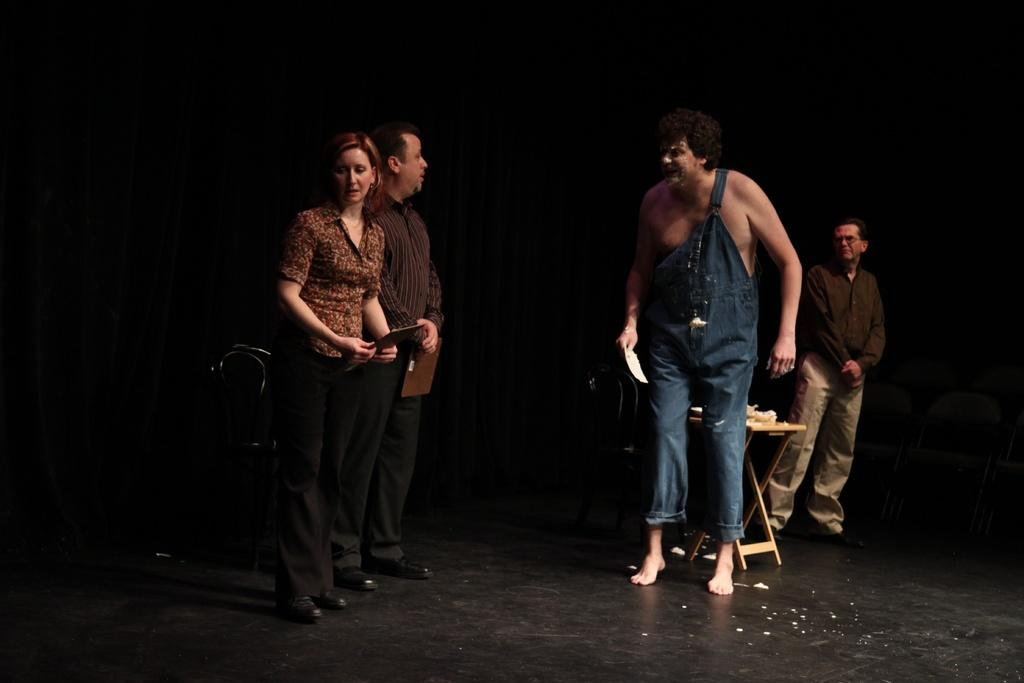What is the main subject of the image? The main subject of the image is a group of people. What are the man and woman holding in the image? The man and woman are holding pads in the image. What type of furniture is present in the image? There is a table and chairs in the image. What type of agreement is being signed by the group of people in the image? There is no indication in the image that the group of people is signing any agreement. 